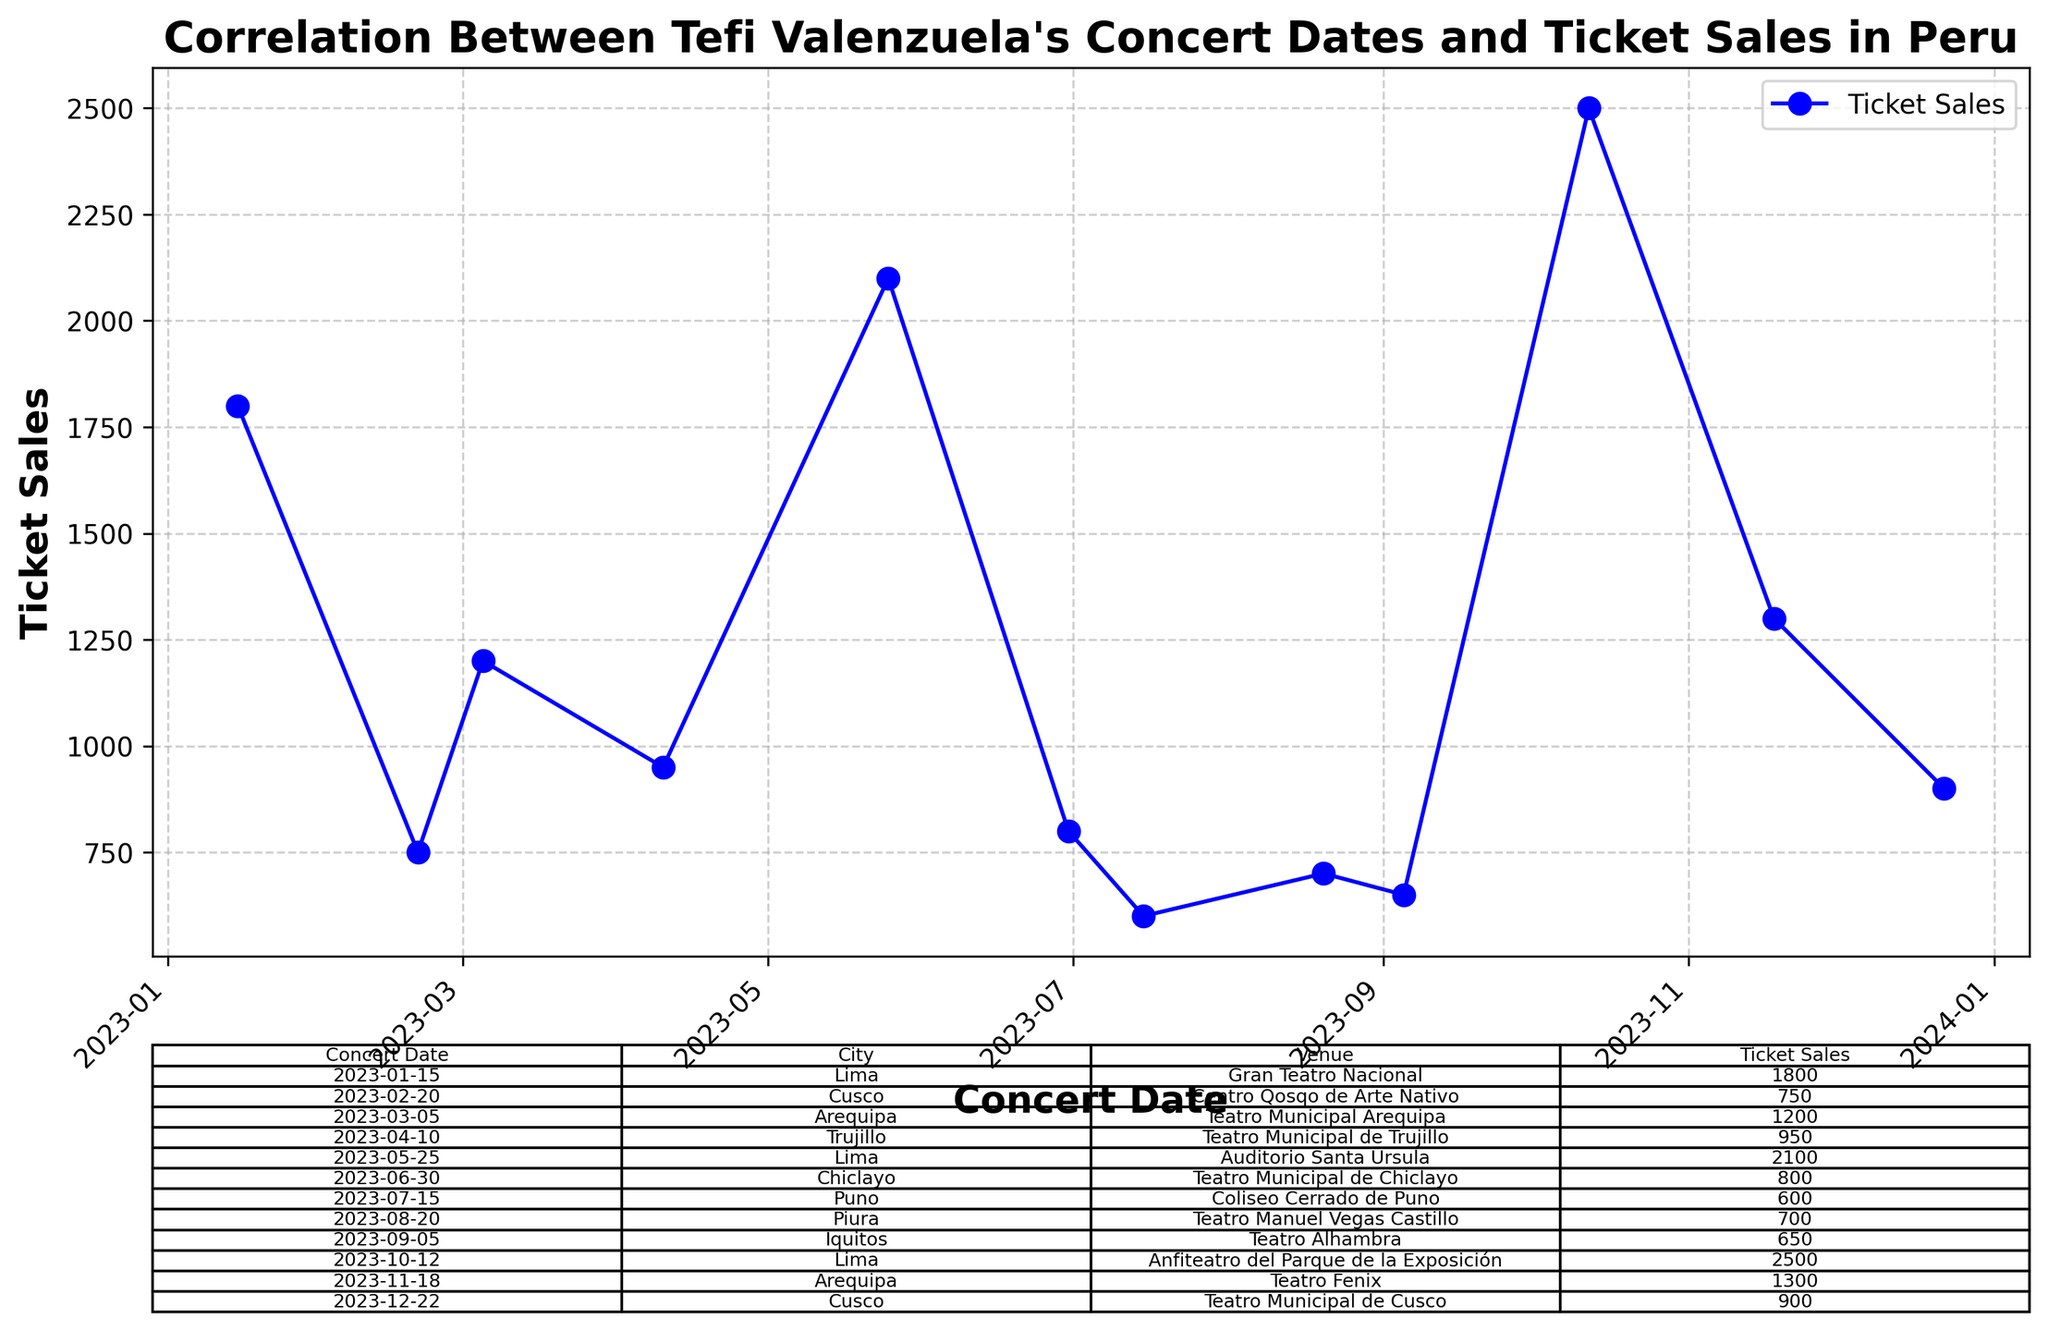What is the total ticket sales for all the concerts held in Lima? To find the total ticket sales for all concerts held in Lima, we sum the ticket sales of the concerts in Lima. According to the data, Lima had concerts on 2023-01-15 (1800 tickets), 2023-05-25 (2100 tickets), and 2023-10-12 (2500 tickets). Adding these up: 1800 + 2100 + 2500 = 6400.
Answer: 6400 Which concert had the highest ticket sales and how much was it? To determine which concert had the highest ticket sales, we look for the highest number in the Ticket Sales column. The highest ticket sales are for the concert in Lima on 2023-10-12 with 2500 tickets sold.
Answer: Lima concert on 2023-10-12 with 2500 tickets What is the average ticket sales across all concerts? To find the average ticket sales, sum up all the ticket sales and divide by the number of concerts. The total ticket sales are 1800 + 750 + 1200 + 950 + 2100 + 800 + 600 + 700 + 650 + 2500 + 1300 + 900 = 14250. There are 12 concerts. So, the average is 14250 / 12 = 1187.5.
Answer: 1187.5 Which city had the lowest ticket sales and what was the value? To find the city with the lowest ticket sales, we look for the lowest number in the Ticket Sales column. The lowest ticket sales were in Puno, with 600 tickets sold on 2023-07-15.
Answer: Puno with 600 tickets Did any two concerts have the same number of ticket sales? To check if any two concerts had the same number of ticket sales, we look for any repeated values in the Ticket Sales column. No ticket sales numbers are repeated, indicating all are unique.
Answer: No How many concerts had ticket sales above 1000? Count the number of concerts where the ticket sales are above 1000 by checking the Ticket Sales column. The concerts with ticket sales above 1000 are 1800, 1200, 2100, 2500, and 1300. There are 5 such concerts.
Answer: 5 What was the date and venue for the concert held in Arequipa with the highest ticket sales? To find the date and venue for the Arequipa concert with the highest ticket sales, look at the entries for Arequipa and compare their ticket sales. The highest sales were on 2023-11-18 at Teatro Fenix with 1300 tickets sold.
Answer: 2023-11-18 at Teatro Fenix Was there an increasing or decreasing trend in ticket sales over the year? Observe the plotted trend line in the figure. The ticket sales start relatively high, then decrease, and fluctuate throughout the year, with peaks in April, May, October, and November, indicating no clear increasing or decreasing trend.
Answer: Fluctuating trend Which month had the highest total ticket sales? Sum the ticket sales for each month and compare. The months with concerts are January, February, March, April, May, June, July, August, September, October, November, and December. October has the highest ticket sales with 2500 tickets from a single concert.
Answer: October Compare the ticket sales for Cusco concerts in February and December. Which one had higher sales and by how much? To compare the ticket sales for Cusco concerts in February and December, subtract the ticket sales for February from that of December. February had 750 tickets sold, and December had 900 tickets sold. The difference is 900 - 750 = 150 tickets higher in December.
Answer: December by 150 tickets 